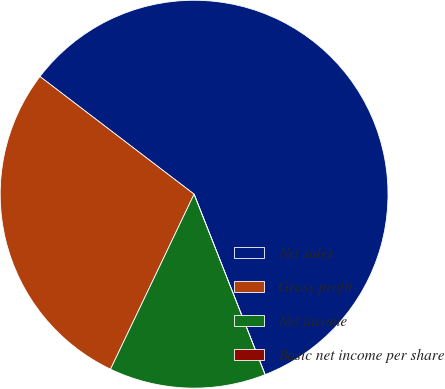Convert chart. <chart><loc_0><loc_0><loc_500><loc_500><pie_chart><fcel>Net sales<fcel>Gross profit<fcel>Net income<fcel>Basic net income per share<nl><fcel>58.66%<fcel>28.29%<fcel>13.06%<fcel>0.0%<nl></chart> 